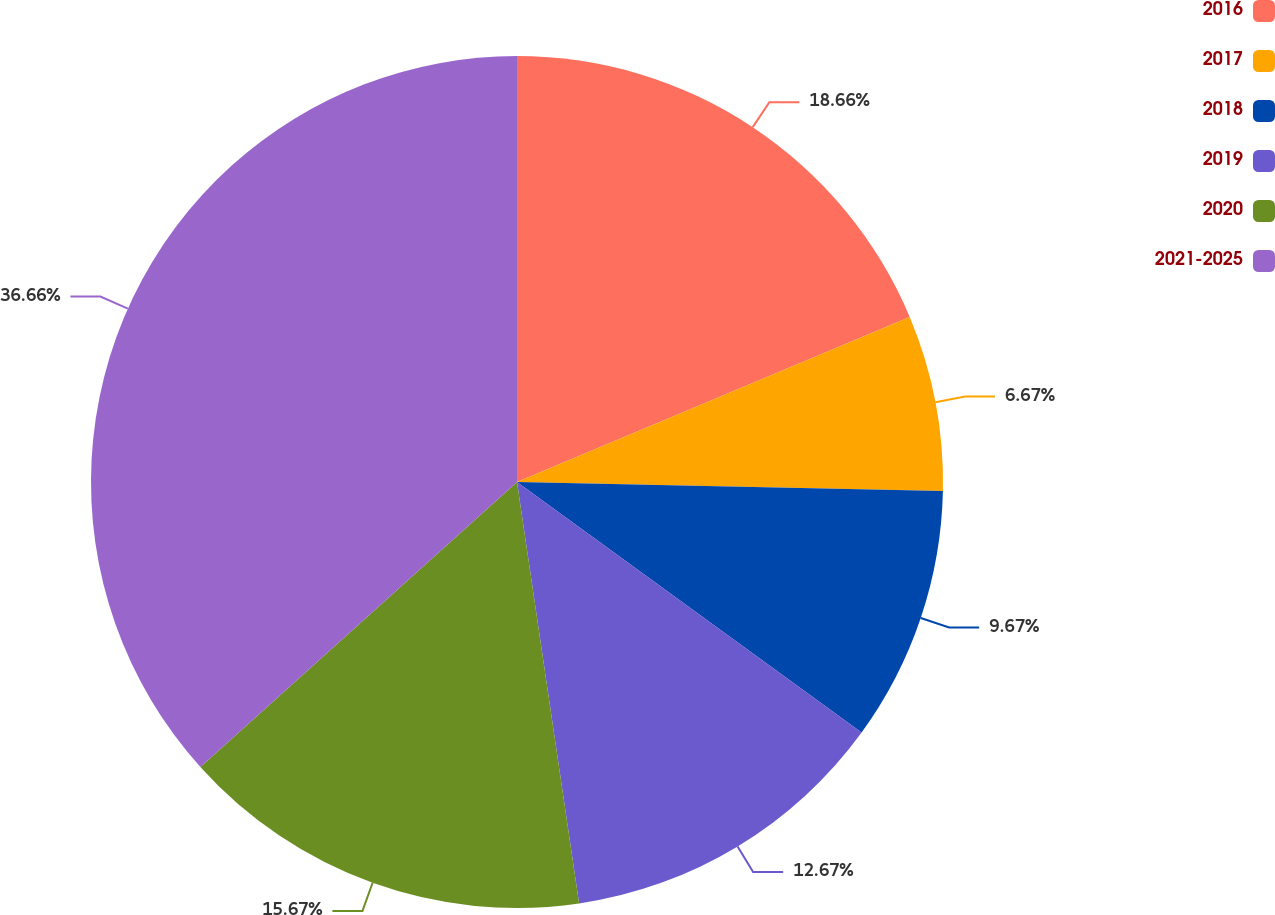Convert chart. <chart><loc_0><loc_0><loc_500><loc_500><pie_chart><fcel>2016<fcel>2017<fcel>2018<fcel>2019<fcel>2020<fcel>2021-2025<nl><fcel>18.67%<fcel>6.67%<fcel>9.67%<fcel>12.67%<fcel>15.67%<fcel>36.67%<nl></chart> 